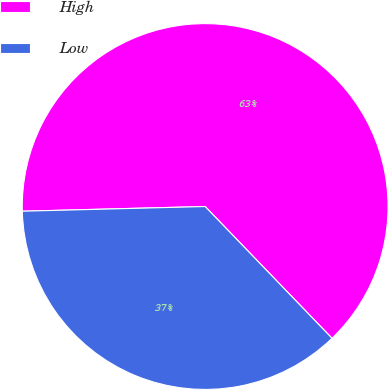<chart> <loc_0><loc_0><loc_500><loc_500><pie_chart><fcel>High<fcel>Low<nl><fcel>63.21%<fcel>36.79%<nl></chart> 